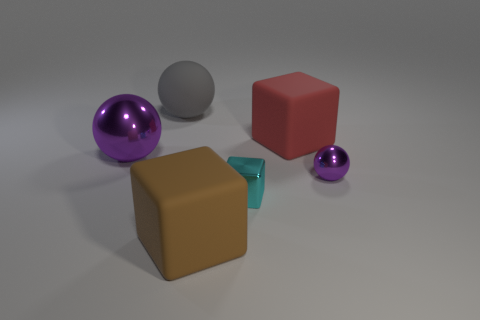Is the color of the small metal cube the same as the large metallic thing?
Ensure brevity in your answer.  No. Is the material of the tiny ball on the right side of the brown matte block the same as the large block to the right of the brown thing?
Provide a succinct answer. No. Are there more small green rubber objects than red matte things?
Your response must be concise. No. Is there anything else that has the same color as the matte sphere?
Provide a short and direct response. No. Are the gray sphere and the cyan block made of the same material?
Offer a very short reply. No. Is the number of large rubber blocks less than the number of matte things?
Offer a very short reply. Yes. Is the shape of the big red thing the same as the tiny purple object?
Offer a very short reply. No. The tiny metal sphere is what color?
Make the answer very short. Purple. What number of other objects are the same material as the big purple sphere?
Give a very brief answer. 2. How many yellow things are either tiny matte things or balls?
Your answer should be compact. 0. 